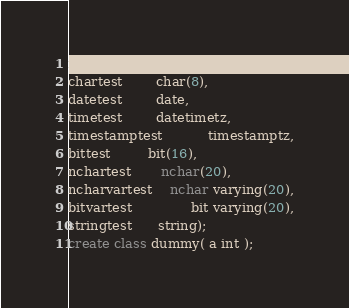Convert code to text. <code><loc_0><loc_0><loc_500><loc_500><_SQL_>moneytest       monetary,
chartest        char(8),
datetest        date,
timetest        datetimetz,
timestamptest           timestamptz,
bittest         bit(16),
nchartest       nchar(20),
ncharvartest    nchar varying(20),
bitvartest              bit varying(20),
stringtest      string);
create class dummy( a int );</code> 